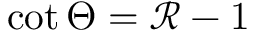<formula> <loc_0><loc_0><loc_500><loc_500>\cot \Theta = \mathcal { R } - 1</formula> 